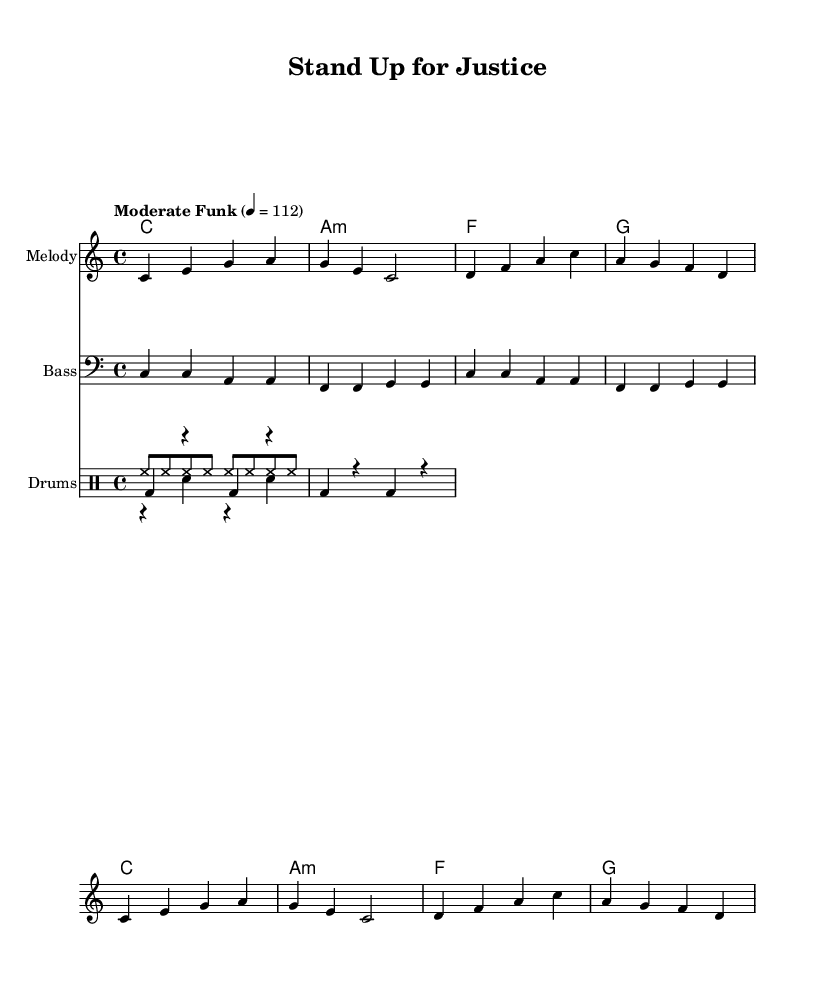What is the key signature of this music? The key signature is C major, which has no sharps or flats.
Answer: C major What is the time signature of this piece? The time signature is 4/4, indicated at the beginning of the score.
Answer: 4/4 What is the tempo marking given in the music? The tempo is marked as "Moderate Funk," with a metronome marking of 112 beats per minute.
Answer: Moderate Funk, 112 How many measures are there in the melody section? The melody section contains 8 measures, as counted from the notation provided.
Answer: 8 measures What chord is played on the first measure of the harmony? The first measure features the chord C major, which is the root chord of the piece.
Answer: C major Which instrument plays the bass line? The bass line is played by the instrument named "Bass," indicated in the score.
Answer: Bass What type of rhythm is used in the hi-hat pattern? The hi-hat pattern consists of steady eighth notes, providing a consistent rhythmic drive typical of funk music.
Answer: Eighth notes 